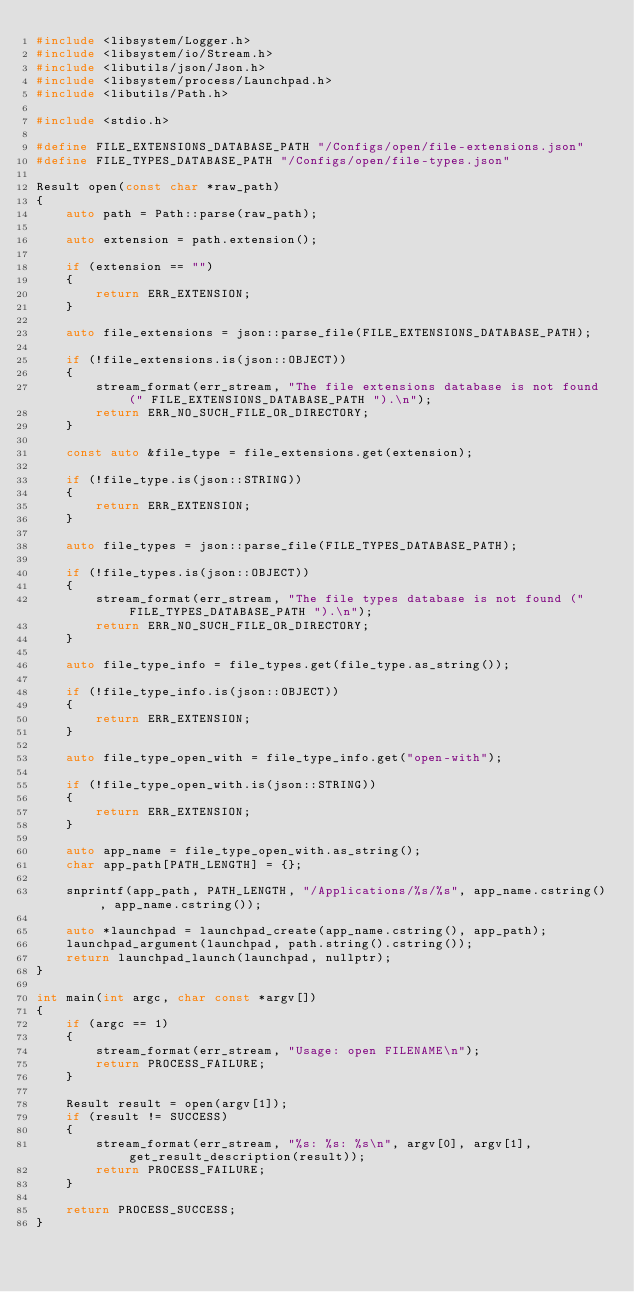Convert code to text. <code><loc_0><loc_0><loc_500><loc_500><_C++_>#include <libsystem/Logger.h>
#include <libsystem/io/Stream.h>
#include <libutils/json/Json.h>
#include <libsystem/process/Launchpad.h>
#include <libutils/Path.h>

#include <stdio.h>

#define FILE_EXTENSIONS_DATABASE_PATH "/Configs/open/file-extensions.json"
#define FILE_TYPES_DATABASE_PATH "/Configs/open/file-types.json"

Result open(const char *raw_path)
{
    auto path = Path::parse(raw_path);

    auto extension = path.extension();

    if (extension == "")
    {
        return ERR_EXTENSION;
    }

    auto file_extensions = json::parse_file(FILE_EXTENSIONS_DATABASE_PATH);

    if (!file_extensions.is(json::OBJECT))
    {
        stream_format(err_stream, "The file extensions database is not found (" FILE_EXTENSIONS_DATABASE_PATH ").\n");
        return ERR_NO_SUCH_FILE_OR_DIRECTORY;
    }

    const auto &file_type = file_extensions.get(extension);

    if (!file_type.is(json::STRING))
    {
        return ERR_EXTENSION;
    }

    auto file_types = json::parse_file(FILE_TYPES_DATABASE_PATH);

    if (!file_types.is(json::OBJECT))
    {
        stream_format(err_stream, "The file types database is not found (" FILE_TYPES_DATABASE_PATH ").\n");
        return ERR_NO_SUCH_FILE_OR_DIRECTORY;
    }

    auto file_type_info = file_types.get(file_type.as_string());

    if (!file_type_info.is(json::OBJECT))
    {
        return ERR_EXTENSION;
    }

    auto file_type_open_with = file_type_info.get("open-with");

    if (!file_type_open_with.is(json::STRING))
    {
        return ERR_EXTENSION;
    }

    auto app_name = file_type_open_with.as_string();
    char app_path[PATH_LENGTH] = {};

    snprintf(app_path, PATH_LENGTH, "/Applications/%s/%s", app_name.cstring(), app_name.cstring());

    auto *launchpad = launchpad_create(app_name.cstring(), app_path);
    launchpad_argument(launchpad, path.string().cstring());
    return launchpad_launch(launchpad, nullptr);
}

int main(int argc, char const *argv[])
{
    if (argc == 1)
    {
        stream_format(err_stream, "Usage: open FILENAME\n");
        return PROCESS_FAILURE;
    }

    Result result = open(argv[1]);
    if (result != SUCCESS)
    {
        stream_format(err_stream, "%s: %s: %s\n", argv[0], argv[1], get_result_description(result));
        return PROCESS_FAILURE;
    }

    return PROCESS_SUCCESS;
}
</code> 